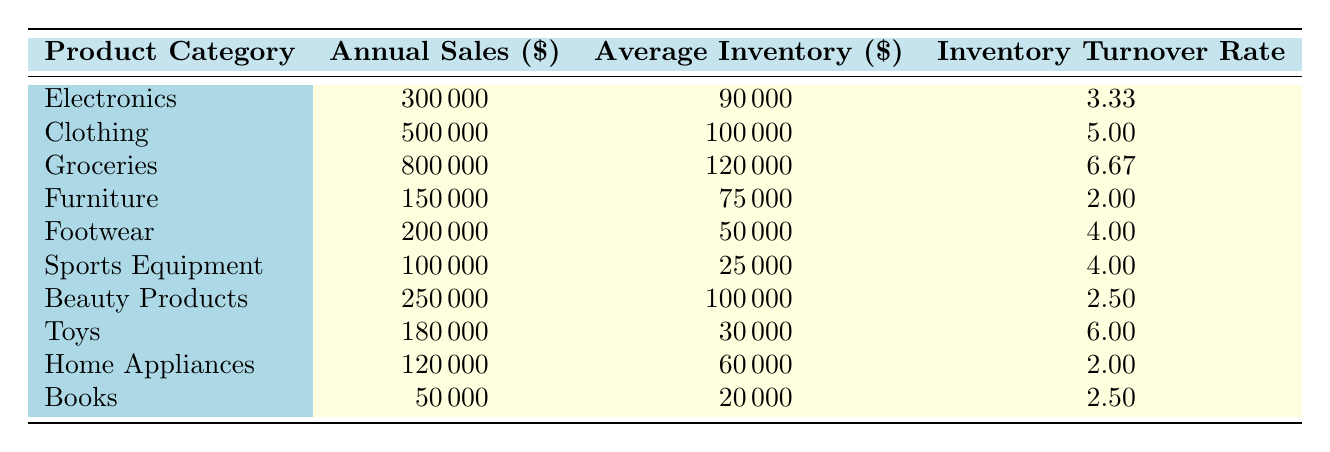What is the Inventory Turnover Rate for the Clothing category? The table lists the Clothing category under the Product Category column, showing an Inventory Turnover Rate of 5.00 in the corresponding row.
Answer: 5.00 Which product category has the highest Inventory Turnover Rate? By examining the Inventory Turnover Rate values listed in the table, Groceries has the highest value of 6.67.
Answer: Groceries How many categories have an Inventory Turnover Rate greater than 4.00? Summarizing the Inventory Turnover Rates, Clothing (5.00), Groceries (6.67), Footwear (4.00), Sports Equipment (4.00), and Toys (6.00) are the categories with an Inventory Turnover Rate greater than 4.00, making a total of 5 categories.
Answer: 5 Is the Average Inventory for Electronics greater than the Average Inventory for Furniture? The Average Inventory for Electronics is 90,000 while for Furniture it is 75,000. Since 90,000 is greater than 75,000, the answer is yes.
Answer: Yes What is the average Inventory Turnover Rate for all product categories? To find the average, sum all Inventory Turnover Rates (3.33 + 5.00 + 6.67 + 2.00 + 4.00 + 4.00 + 2.50 + 6.00 + 2.00 + 2.50 = 36.00) and divide by the number of categories (10). The result is 36.00 / 10 = 3.60.
Answer: 3.60 Which categories have an Average Inventory less than 60,000? From the table, the categories with Average Inventory less than 60,000 are Sports Equipment (25,000), Footwear (50,000), and Toys (30,000). Counting these gives a total of 3 categories.
Answer: 3 Is it true that Beauty Products have a higher Annual Sales than Furniture? The Annual Sales for Beauty Products is 250,000 while for Furniture it is 150,000. Since 250,000 is greater than 150,000, the answer is yes.
Answer: Yes What is the difference in Average Inventory between the category with the highest and the lowest Inventory Turnover Rates? The highest Inventory Turnover Rate is Groceries (6.67) with an Average Inventory of 120,000, and the lowest is Furniture (2.00) with an Average Inventory of 75,000. The difference in Average Inventory is 120,000 - 75,000 = 45,000.
Answer: 45,000 How do the Inventory Turnover Rates for Footwear and Sports Equipment compare? Both Footwear and Sports Equipment have the same Inventory Turnover Rate of 4.00, indicating they perform identically in terms of inventory turnover.
Answer: They are equal 